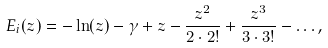<formula> <loc_0><loc_0><loc_500><loc_500>E _ { i } ( z ) = - \ln ( z ) - \gamma + z - \frac { z ^ { 2 } } { 2 \cdot 2 ! } + \frac { z ^ { 3 } } { 3 \cdot 3 ! } - \dots ,</formula> 